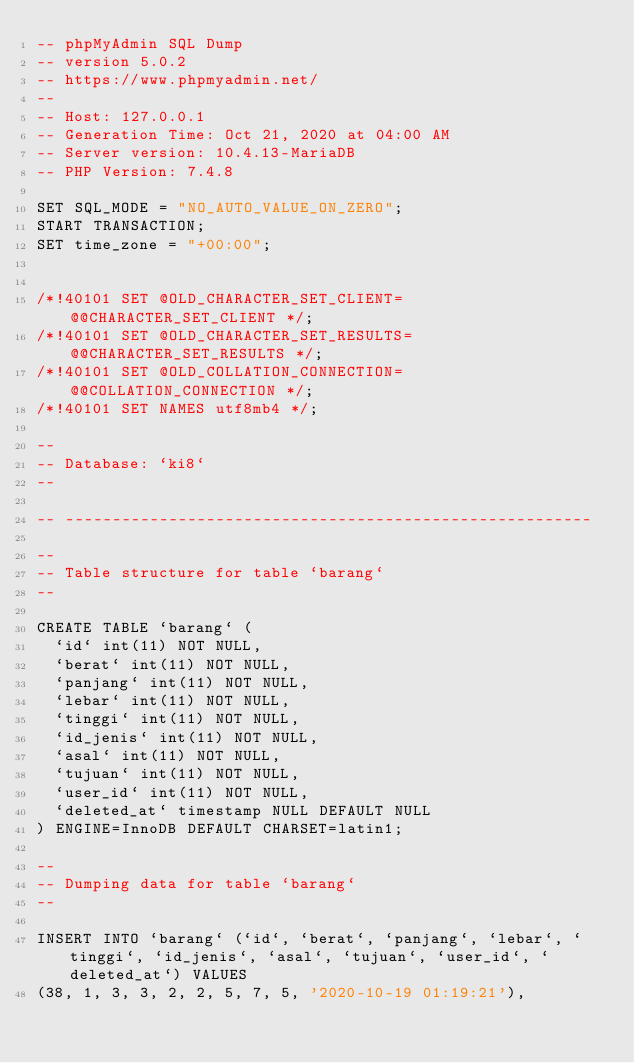Convert code to text. <code><loc_0><loc_0><loc_500><loc_500><_SQL_>-- phpMyAdmin SQL Dump
-- version 5.0.2
-- https://www.phpmyadmin.net/
--
-- Host: 127.0.0.1
-- Generation Time: Oct 21, 2020 at 04:00 AM
-- Server version: 10.4.13-MariaDB
-- PHP Version: 7.4.8

SET SQL_MODE = "NO_AUTO_VALUE_ON_ZERO";
START TRANSACTION;
SET time_zone = "+00:00";


/*!40101 SET @OLD_CHARACTER_SET_CLIENT=@@CHARACTER_SET_CLIENT */;
/*!40101 SET @OLD_CHARACTER_SET_RESULTS=@@CHARACTER_SET_RESULTS */;
/*!40101 SET @OLD_COLLATION_CONNECTION=@@COLLATION_CONNECTION */;
/*!40101 SET NAMES utf8mb4 */;

--
-- Database: `ki8`
--

-- --------------------------------------------------------

--
-- Table structure for table `barang`
--

CREATE TABLE `barang` (
  `id` int(11) NOT NULL,
  `berat` int(11) NOT NULL,
  `panjang` int(11) NOT NULL,
  `lebar` int(11) NOT NULL,
  `tinggi` int(11) NOT NULL,
  `id_jenis` int(11) NOT NULL,
  `asal` int(11) NOT NULL,
  `tujuan` int(11) NOT NULL,
  `user_id` int(11) NOT NULL,
  `deleted_at` timestamp NULL DEFAULT NULL
) ENGINE=InnoDB DEFAULT CHARSET=latin1;

--
-- Dumping data for table `barang`
--

INSERT INTO `barang` (`id`, `berat`, `panjang`, `lebar`, `tinggi`, `id_jenis`, `asal`, `tujuan`, `user_id`, `deleted_at`) VALUES
(38, 1, 3, 3, 2, 2, 5, 7, 5, '2020-10-19 01:19:21'),</code> 